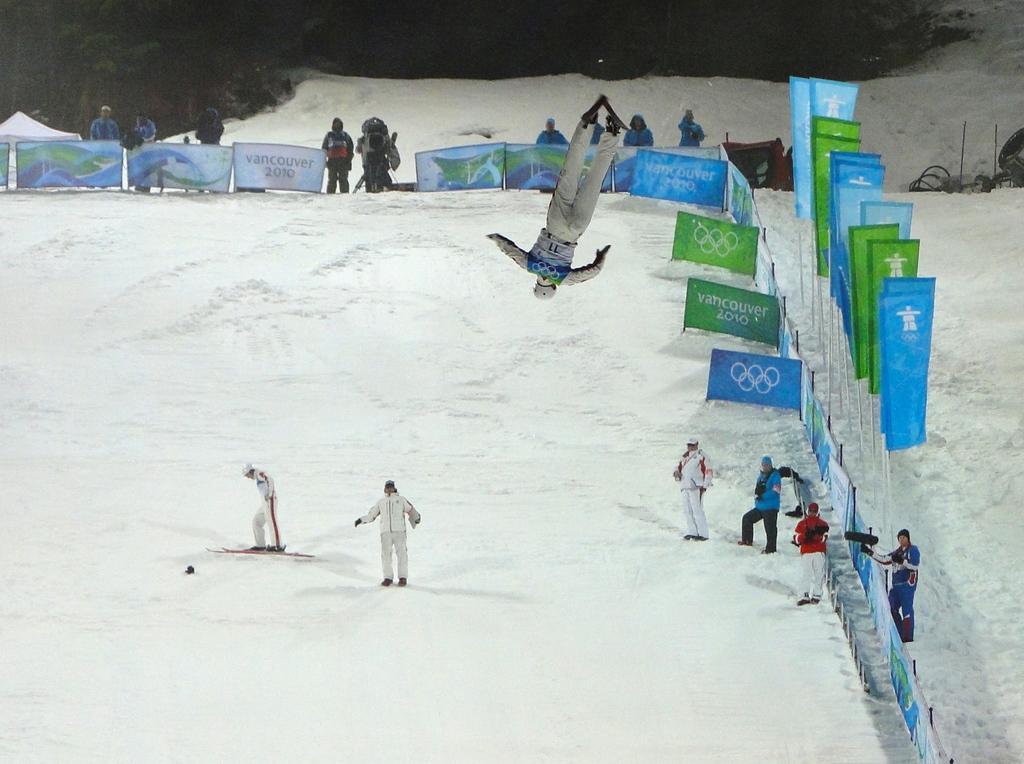Could you give a brief overview of what you see in this image? Background portion of the picture is dark. In this picture we can see the banners, snow and a person in the air. We can see the people skating on the snow. Few people are standing on the right side and few people are standing in the background. We can see few objects. 